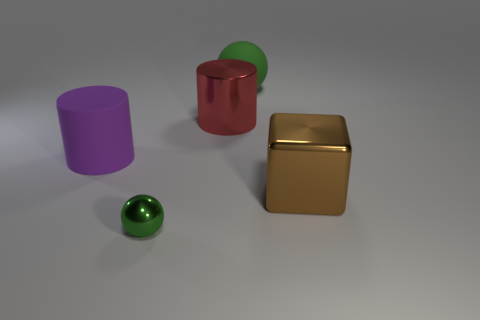Add 3 red metallic objects. How many objects exist? 8 Subtract all cylinders. How many objects are left? 3 Subtract all red shiny objects. Subtract all tiny green things. How many objects are left? 3 Add 5 purple matte things. How many purple matte things are left? 6 Add 1 big green cubes. How many big green cubes exist? 1 Subtract 0 blue cylinders. How many objects are left? 5 